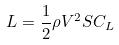Convert formula to latex. <formula><loc_0><loc_0><loc_500><loc_500>L = \frac { 1 } { 2 } \rho V ^ { 2 } S C _ { L }</formula> 